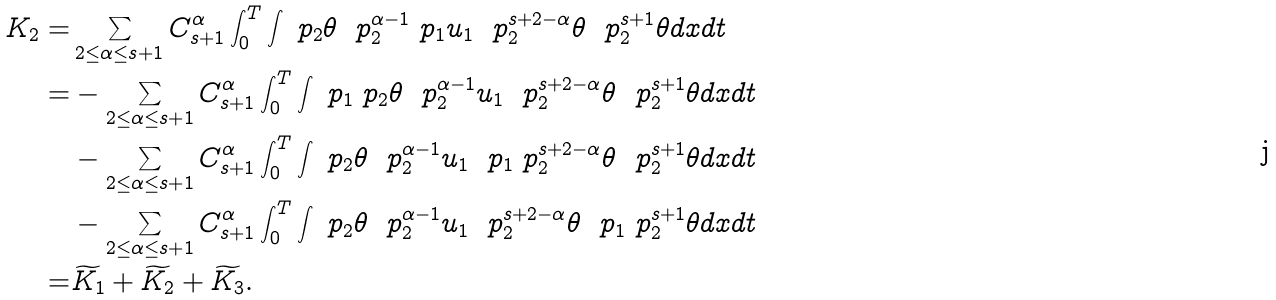Convert formula to latex. <formula><loc_0><loc_0><loc_500><loc_500>K _ { 2 } = & \sum _ { 2 \leq \alpha \leq s + 1 } C _ { s + 1 } ^ { \alpha } \int _ { 0 } ^ { T } \int \ p _ { 2 } \theta \ \ p _ { 2 } ^ { \alpha - 1 } \ p _ { 1 } u _ { 1 } \ \ p _ { 2 } ^ { s + 2 - \alpha } \theta \ \ p _ { 2 } ^ { s + 1 } \theta d x d t \\ = & - \sum _ { 2 \leq \alpha \leq s + 1 } C _ { s + 1 } ^ { \alpha } \int _ { 0 } ^ { T } \int \ p _ { 1 } \ p _ { 2 } \theta \ \ p _ { 2 } ^ { \alpha - 1 } u _ { 1 } \ \ p _ { 2 } ^ { s + 2 - \alpha } \theta \ \ p _ { 2 } ^ { s + 1 } \theta d x d t \\ & - \sum _ { 2 \leq \alpha \leq s + 1 } C _ { s + 1 } ^ { \alpha } \int _ { 0 } ^ { T } \int \ p _ { 2 } \theta \ \ p _ { 2 } ^ { \alpha - 1 } u _ { 1 } \ \ p _ { 1 } \ p _ { 2 } ^ { s + 2 - \alpha } \theta \ \ p _ { 2 } ^ { s + 1 } \theta d x d t \\ & - \sum _ { 2 \leq \alpha \leq s + 1 } C _ { s + 1 } ^ { \alpha } \int _ { 0 } ^ { T } \int \ p _ { 2 } \theta \ \ p _ { 2 } ^ { \alpha - 1 } u _ { 1 } \ \ p _ { 2 } ^ { s + 2 - \alpha } \theta \ \ p _ { 1 } \ p _ { 2 } ^ { s + 1 } \theta d x d t \\ = & \widetilde { K _ { 1 } } + \widetilde { K _ { 2 } } + \widetilde { K _ { 3 } } .</formula> 